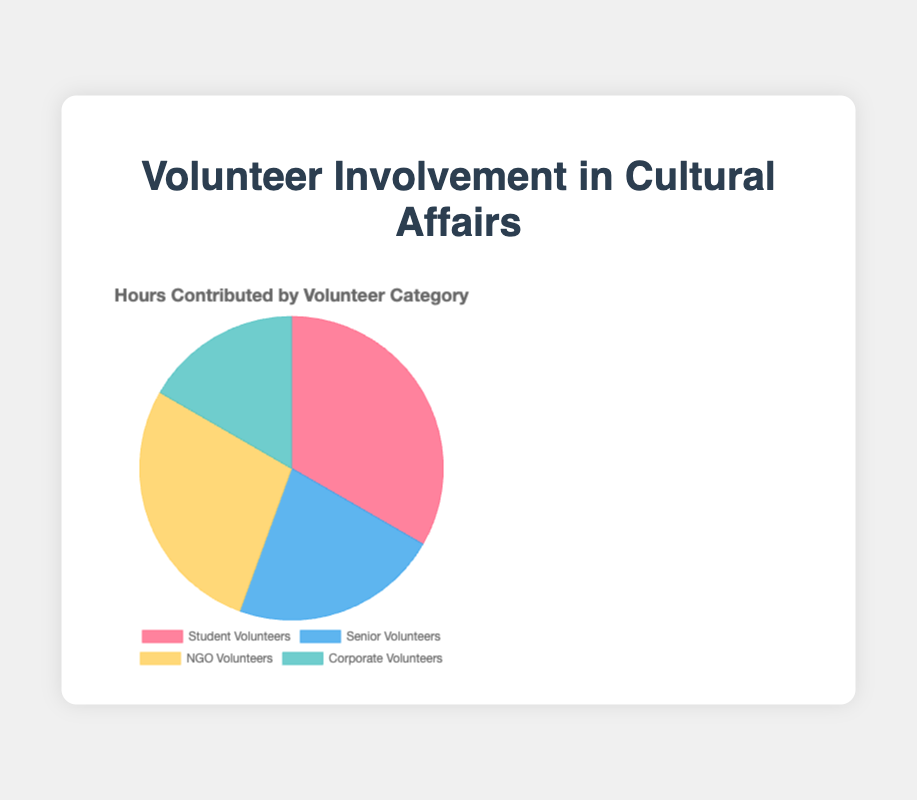what percentage of total volunteer hours were contributed by senior volunteers? To find the percentage, divide the hours contributed by senior volunteers by the total hours contributed by all volunteers and multiply by 100. The total hours are 1200 + 800 + 1000 + 600 = 3600. So, the calculation is (800 / 3600) * 100 = 22.22%.
Answer: 22.22% which group contributed the most hours? Refer to the chart to find the group with the largest section. The largest section is for "Student Volunteers" which contributed 1200 hours.
Answer: Student Volunteers how do corporate volunteer hours compare to ngo volunteer hours? Look at the chart and compare the sizes of the sections. "Corporate Volunteers" contributed 600 hours while "NGO Volunteers" contributed 1000 hours. Corporate volunteer hours are less than NGO volunteer hours.
Answer: Less which sector has the smallest contribution in terms of hours? Identify the smallest section of the pie chart, which represents the smallest contribution. This is the "Corporate Volunteers" with 600 hours.
Answer: Corporate Volunteers what is the total number of volunteer hours contributed? Sum the hours contributed by all the categories. That is, 1200 (Student) + 800 (Senior) + 1000 (NGO) + 600 (Corporate) = 3600 hours.
Answer: 3600 how many more hours did student volunteers contribute compared to corporate volunteers? Subtract the hours contributed by Corporate Volunteers from those contributed by Student Volunteers. The calculation is 1200 - 600 = 600 hours.
Answer: 600 hours is there more than twice the contribution from student volunteers compared to corporate volunteers? To determine if Student Volunteers contributed more than twice the hours of Corporate Volunteers, compare twice the Corporate Volunteers' hours (2 * 600) with Student Volunteers' hours. Since 2 * 600 = 1200 and Student Volunteers contributed 1200 hours, the condition is just met.
Answer: Yes what is the average number of volunteer hours contributed by each group? Calculate the total hours contributed (3600) and divide by the number of groups (4). So, 3600 / 4 = 900 hours per group on average.
Answer: 900 which volunteer category has the closest contribution to the average hours? Find the average hours contributed per group (900 hours) and then identify the category with hours closest to this average. Senior Volunteers contributed 800 hours, which is the closest to the average of 900 hours.
Answer: Senior Volunteers 